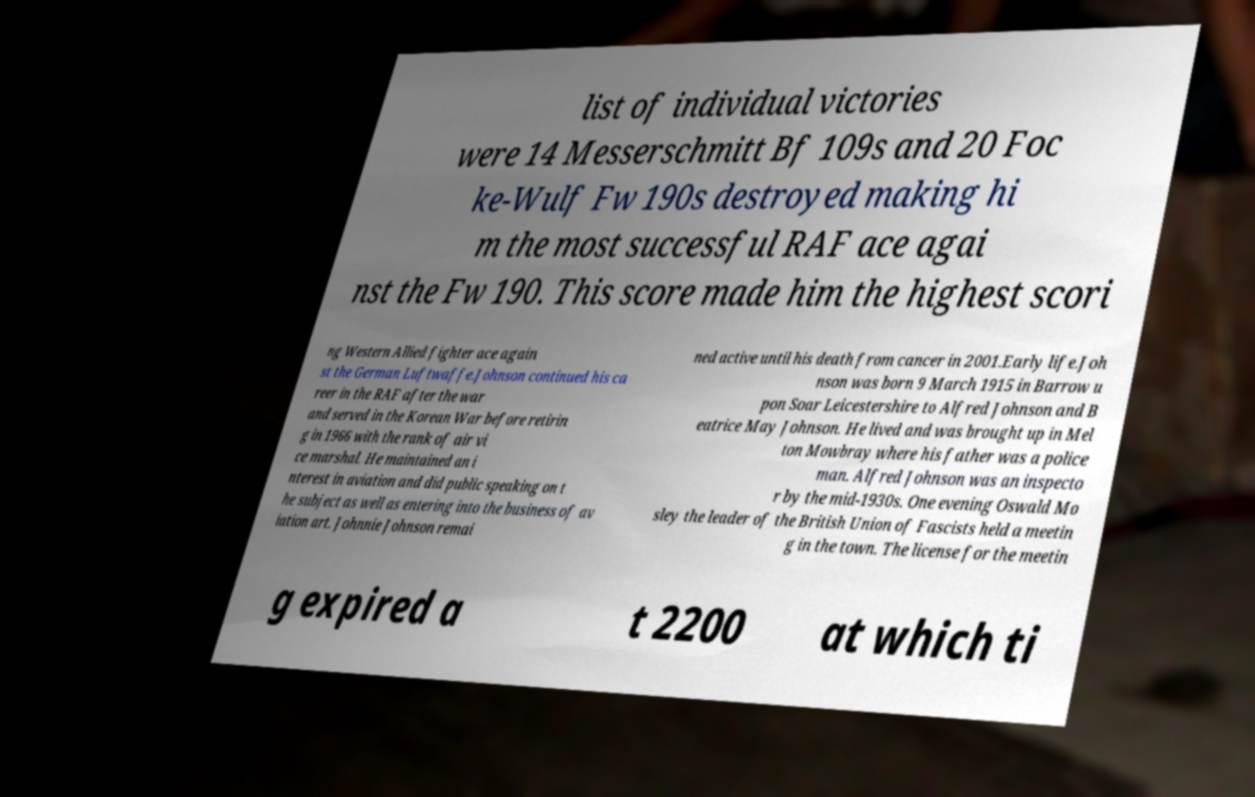Please read and relay the text visible in this image. What does it say? list of individual victories were 14 Messerschmitt Bf 109s and 20 Foc ke-Wulf Fw 190s destroyed making hi m the most successful RAF ace agai nst the Fw 190. This score made him the highest scori ng Western Allied fighter ace again st the German Luftwaffe.Johnson continued his ca reer in the RAF after the war and served in the Korean War before retirin g in 1966 with the rank of air vi ce marshal. He maintained an i nterest in aviation and did public speaking on t he subject as well as entering into the business of av iation art. Johnnie Johnson remai ned active until his death from cancer in 2001.Early life.Joh nson was born 9 March 1915 in Barrow u pon Soar Leicestershire to Alfred Johnson and B eatrice May Johnson. He lived and was brought up in Mel ton Mowbray where his father was a police man. Alfred Johnson was an inspecto r by the mid-1930s. One evening Oswald Mo sley the leader of the British Union of Fascists held a meetin g in the town. The license for the meetin g expired a t 2200 at which ti 